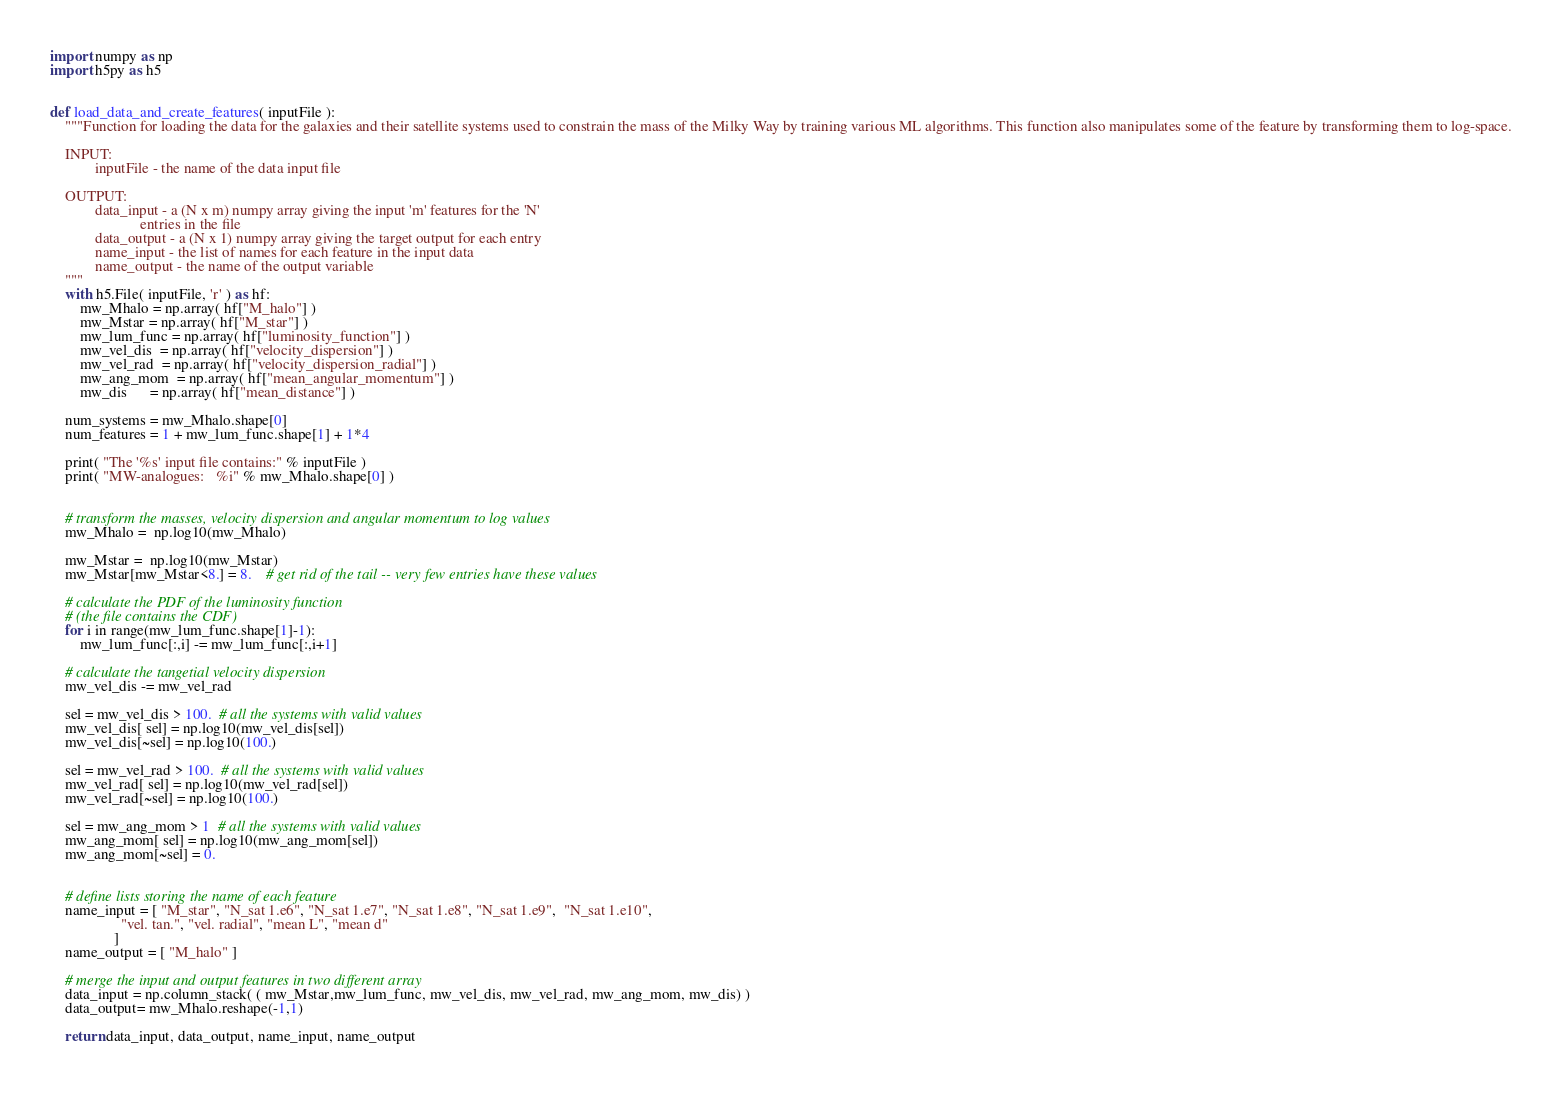Convert code to text. <code><loc_0><loc_0><loc_500><loc_500><_Python_>import numpy as np
import h5py as h5


def load_data_and_create_features( inputFile ):
    """Function for loading the data for the galaxies and their satellite systems used to constrain the mass of the Milky Way by training various ML algorithms. This function also manipulates some of the feature by transforming them to log-space.
    
    INPUT:
            inputFile - the name of the data input file
    
    OUTPUT:
            data_input - a (N x m) numpy array giving the input 'm' features for the 'N' 
                        entries in the file
            data_output - a (N x 1) numpy array giving the target output for each entry
            name_input - the list of names for each feature in the input data
            name_output - the name of the output variable
    """
    with h5.File( inputFile, 'r' ) as hf:
        mw_Mhalo = np.array( hf["M_halo"] )
        mw_Mstar = np.array( hf["M_star"] )
        mw_lum_func = np.array( hf["luminosity_function"] )
        mw_vel_dis  = np.array( hf["velocity_dispersion"] )
        mw_vel_rad  = np.array( hf["velocity_dispersion_radial"] )
        mw_ang_mom  = np.array( hf["mean_angular_momentum"] )
        mw_dis      = np.array( hf["mean_distance"] )

    num_systems = mw_Mhalo.shape[0]
    num_features = 1 + mw_lum_func.shape[1] + 1*4

    print( "The '%s' input file contains:" % inputFile )
    print( "MW-analogues:   %i" % mw_Mhalo.shape[0] )


    # transform the masses, velocity dispersion and angular momentum to log values
    mw_Mhalo =  np.log10(mw_Mhalo)
    
    mw_Mstar =  np.log10(mw_Mstar)
    mw_Mstar[mw_Mstar<8.] = 8.    # get rid of the tail -- very few entries have these values
    
    # calculate the PDF of the luminosity function
    # (the file contains the CDF)
    for i in range(mw_lum_func.shape[1]-1):
        mw_lum_func[:,i] -= mw_lum_func[:,i+1]
    
    # calculate the tangetial velocity dispersion
    mw_vel_dis -= mw_vel_rad
    
    sel = mw_vel_dis > 100.  # all the systems with valid values
    mw_vel_dis[ sel] = np.log10(mw_vel_dis[sel])
    mw_vel_dis[~sel] = np.log10(100.)

    sel = mw_vel_rad > 100.  # all the systems with valid values
    mw_vel_rad[ sel] = np.log10(mw_vel_rad[sel])
    mw_vel_rad[~sel] = np.log10(100.)

    sel = mw_ang_mom > 1  # all the systems with valid values
    mw_ang_mom[ sel] = np.log10(mw_ang_mom[sel])
    mw_ang_mom[~sel] = 0.


    # define lists storing the name of each feature
    name_input = [ "M_star", "N_sat 1.e6", "N_sat 1.e7", "N_sat 1.e8", "N_sat 1.e9",  "N_sat 1.e10", 
                   "vel. tan.", "vel. radial", "mean L", "mean d"
                 ]
    name_output = [ "M_halo" ]

    # merge the input and output features in two different array
    data_input = np.column_stack( ( mw_Mstar,mw_lum_func, mw_vel_dis, mw_vel_rad, mw_ang_mom, mw_dis) )
    data_output= mw_Mhalo.reshape(-1,1)
    
    return data_input, data_output, name_input, name_output </code> 